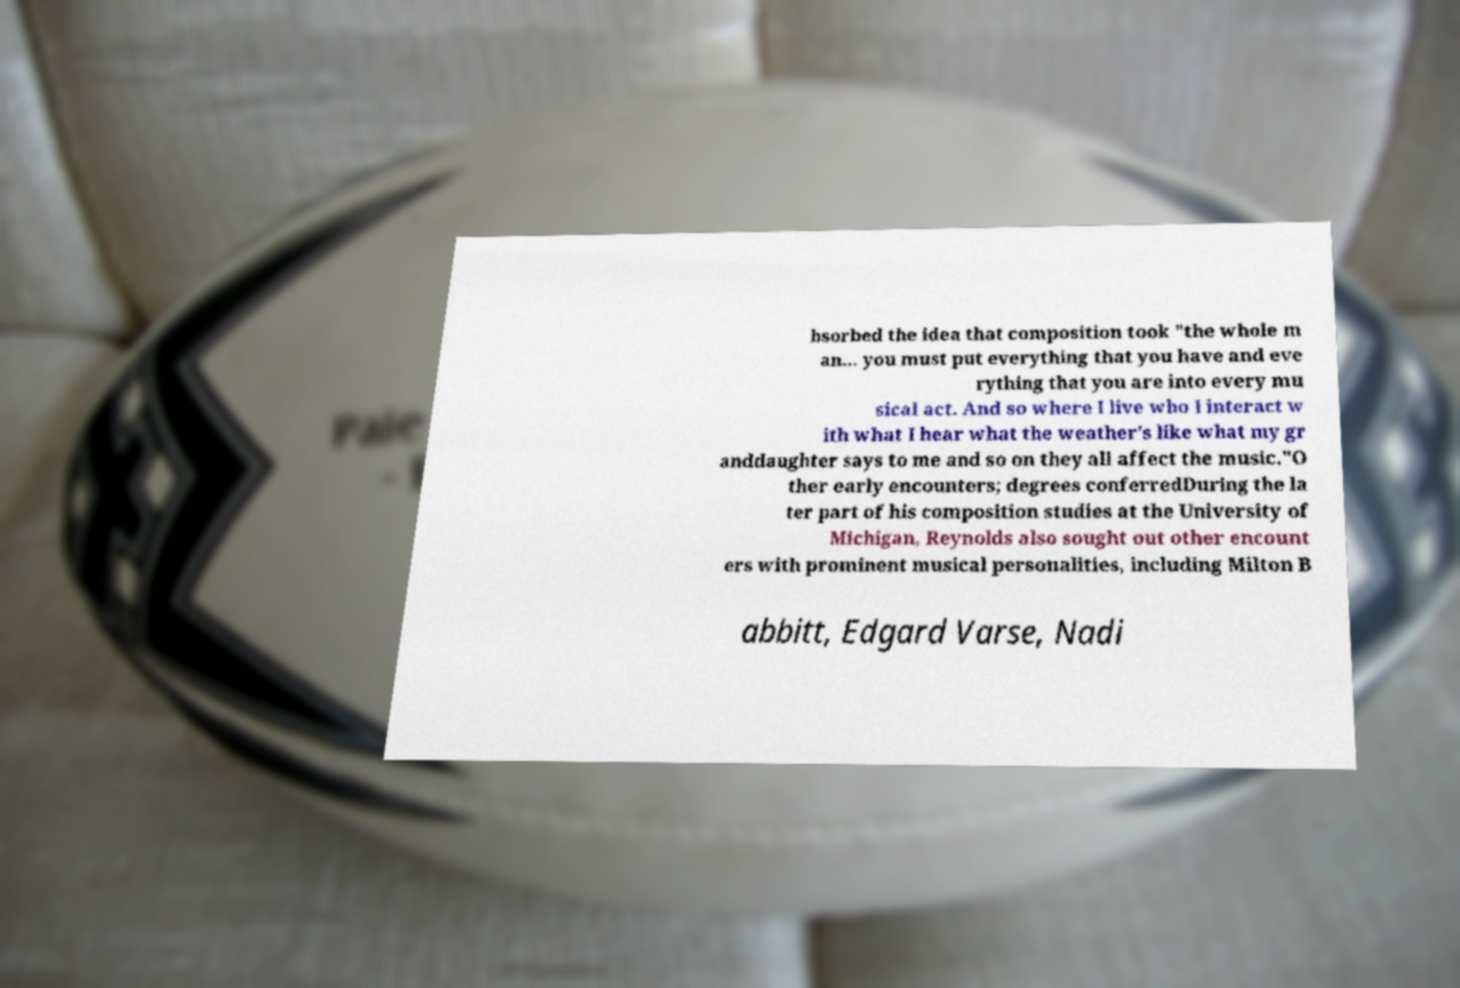For documentation purposes, I need the text within this image transcribed. Could you provide that? bsorbed the idea that composition took "the whole m an... you must put everything that you have and eve rything that you are into every mu sical act. And so where I live who I interact w ith what I hear what the weather’s like what my gr anddaughter says to me and so on they all affect the music."O ther early encounters; degrees conferredDuring the la ter part of his composition studies at the University of Michigan, Reynolds also sought out other encount ers with prominent musical personalities, including Milton B abbitt, Edgard Varse, Nadi 